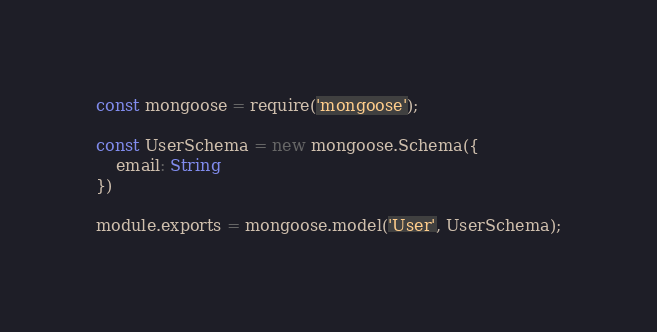<code> <loc_0><loc_0><loc_500><loc_500><_JavaScript_>const mongoose = require('mongoose');

const UserSchema = new mongoose.Schema({
    email: String
})

module.exports = mongoose.model('User', UserSchema);</code> 